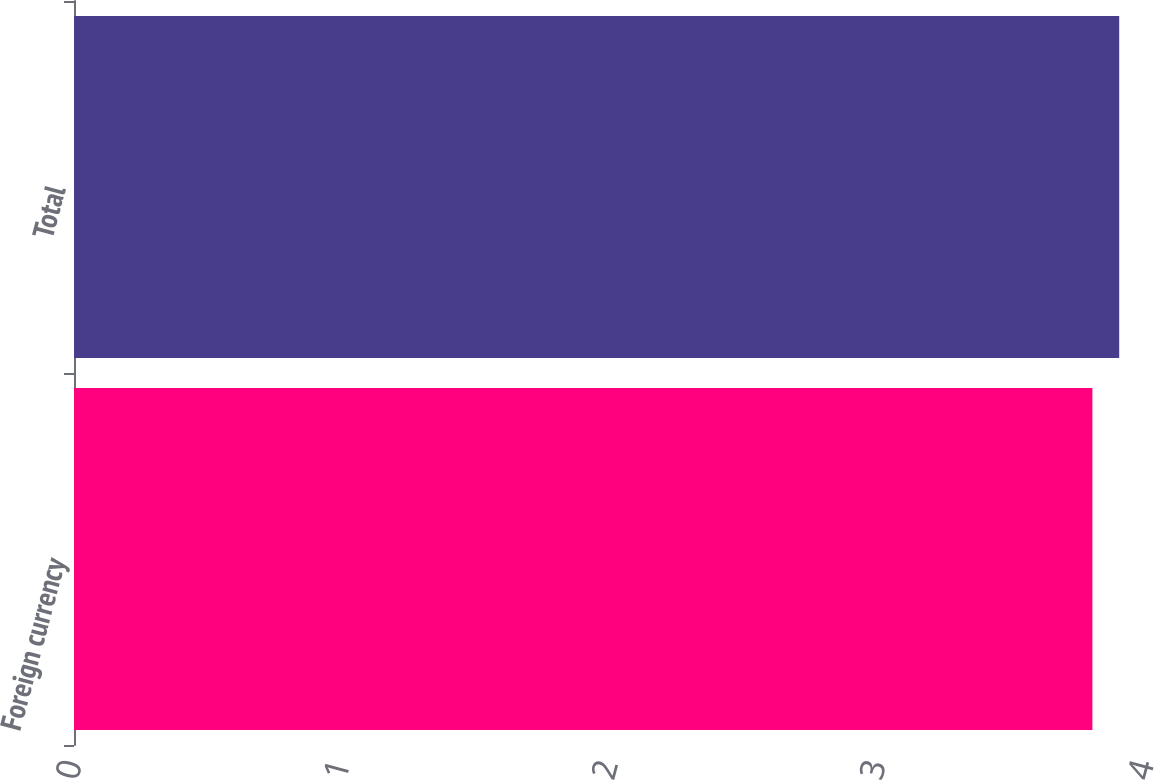<chart> <loc_0><loc_0><loc_500><loc_500><bar_chart><fcel>Foreign currency<fcel>Total<nl><fcel>3.8<fcel>3.9<nl></chart> 